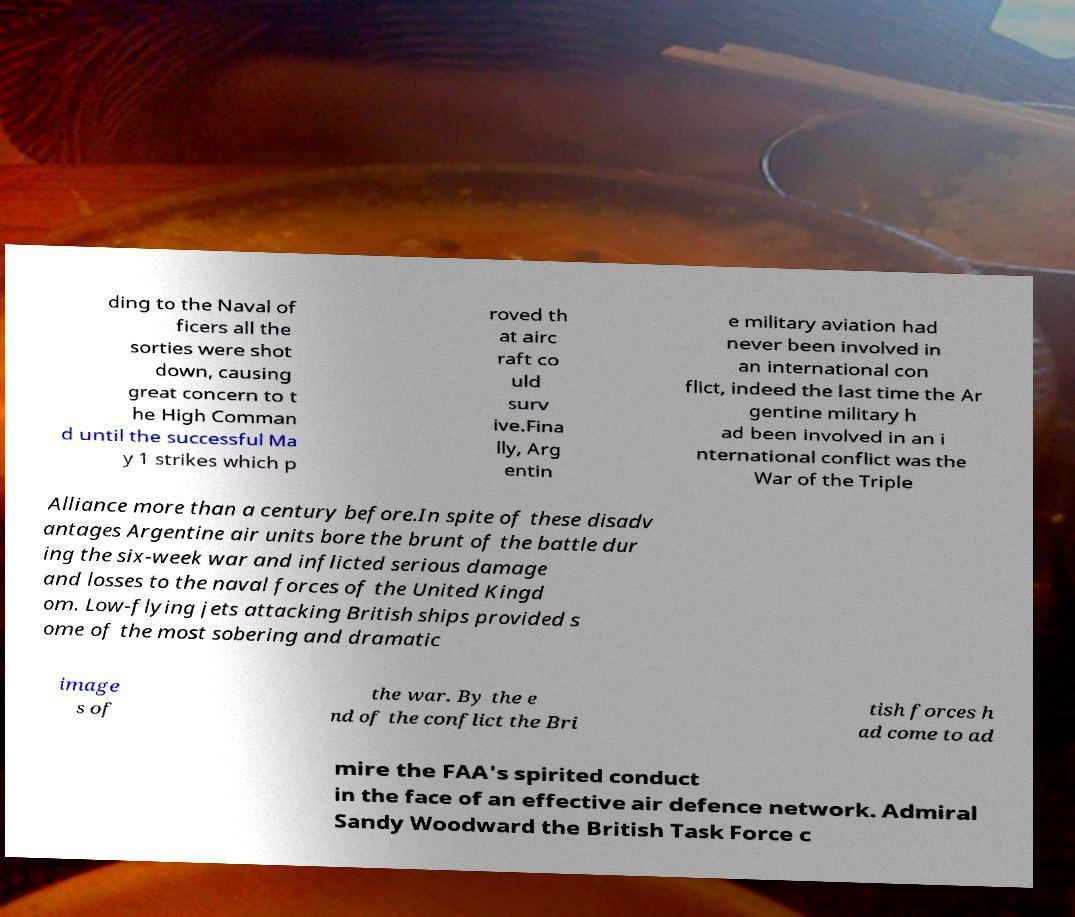What messages or text are displayed in this image? I need them in a readable, typed format. ding to the Naval of ficers all the sorties were shot down, causing great concern to t he High Comman d until the successful Ma y 1 strikes which p roved th at airc raft co uld surv ive.Fina lly, Arg entin e military aviation had never been involved in an international con flict, indeed the last time the Ar gentine military h ad been involved in an i nternational conflict was the War of the Triple Alliance more than a century before.In spite of these disadv antages Argentine air units bore the brunt of the battle dur ing the six-week war and inflicted serious damage and losses to the naval forces of the United Kingd om. Low-flying jets attacking British ships provided s ome of the most sobering and dramatic image s of the war. By the e nd of the conflict the Bri tish forces h ad come to ad mire the FAA's spirited conduct in the face of an effective air defence network. Admiral Sandy Woodward the British Task Force c 